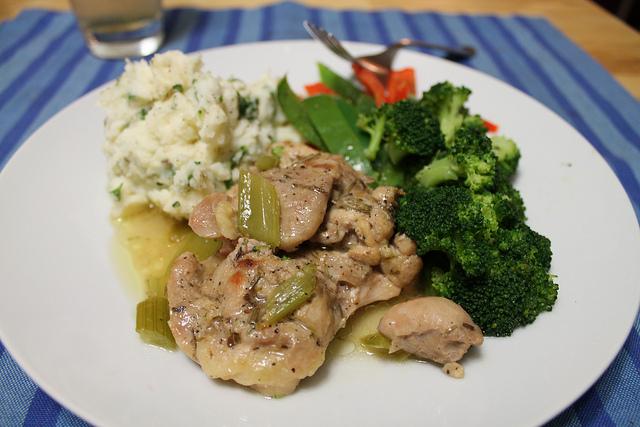What kind of meat is this?
Short answer required. Chicken. For what meal of the day is this probably eaten?
Concise answer only. Dinner. Name a vegetable?
Write a very short answer. Broccoli. What pattern is the tablecloth?
Short answer required. Stripes. Is this food cooked or raw?
Short answer required. Cooked. What kind of food is this?
Quick response, please. Chicken. 